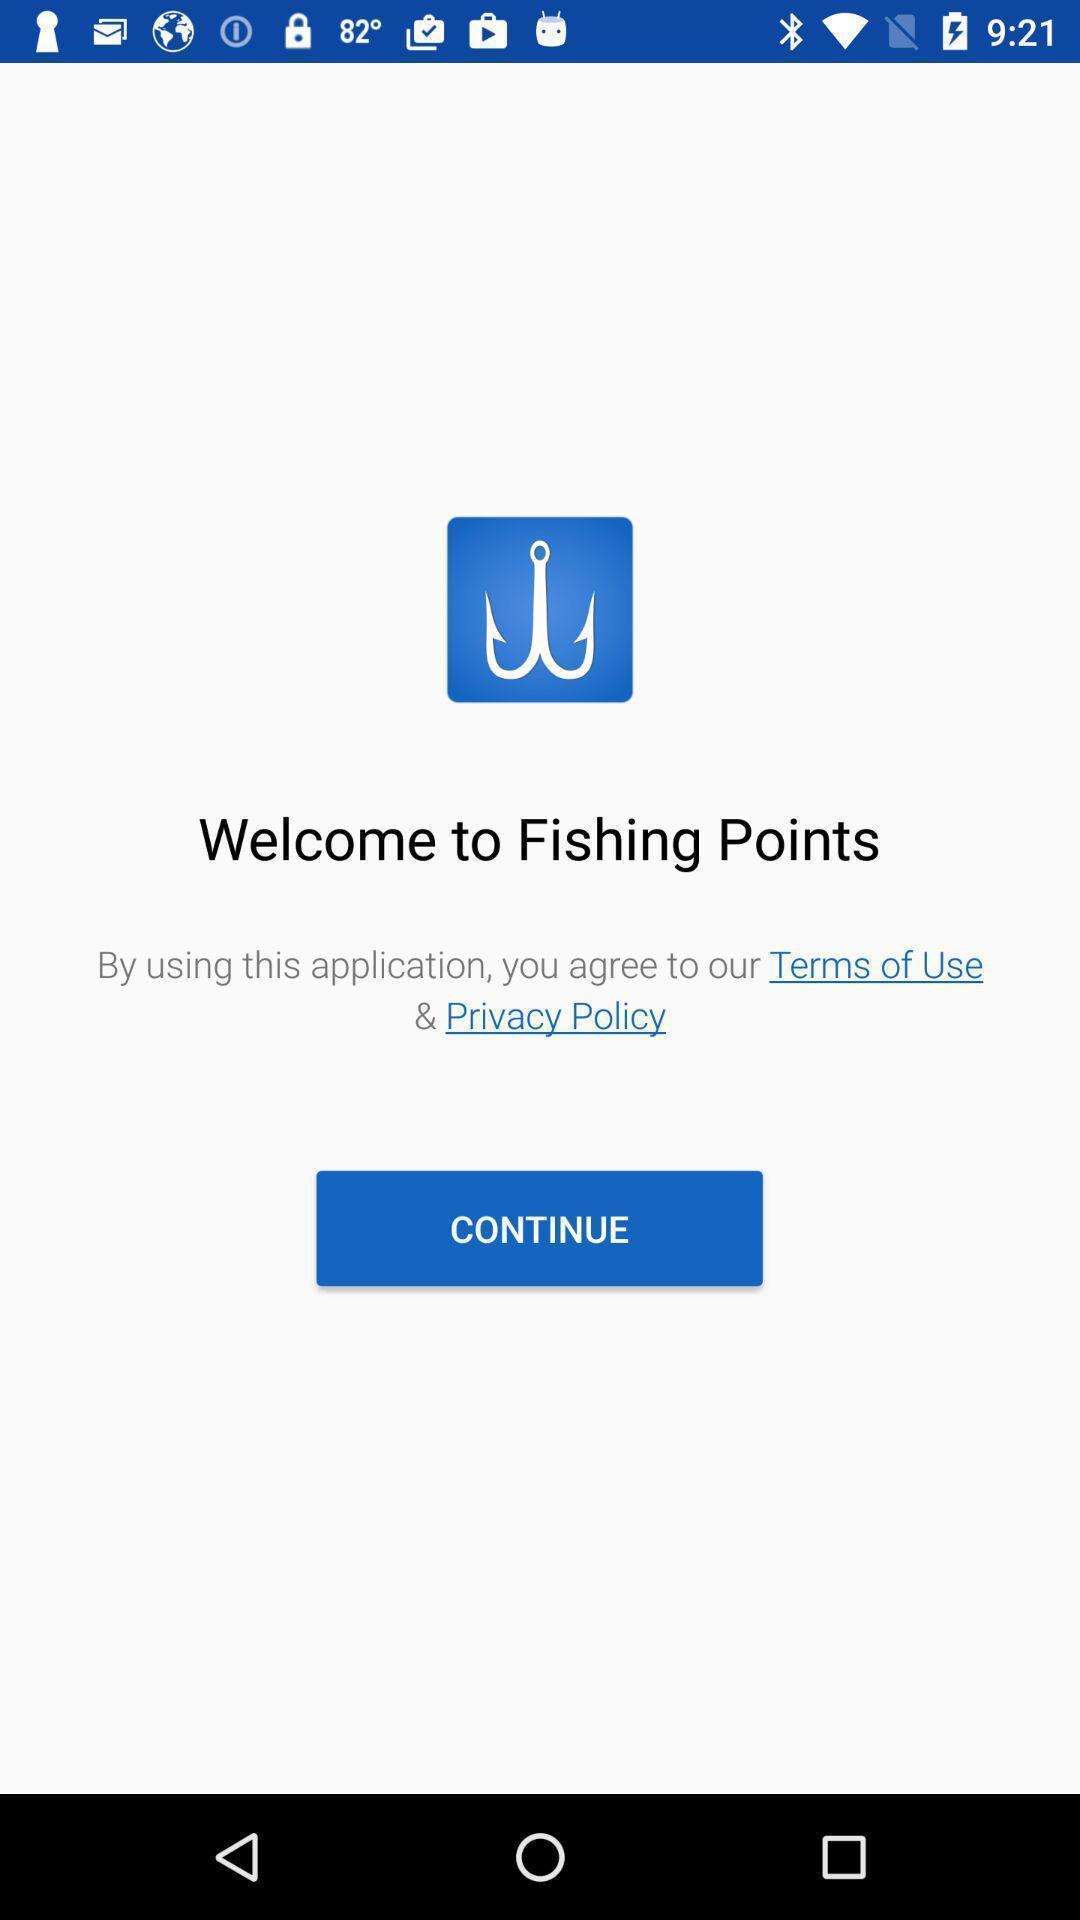Provide a textual representation of this image. Welcome page of fishing application. 